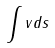Convert formula to latex. <formula><loc_0><loc_0><loc_500><loc_500>\int v d s</formula> 